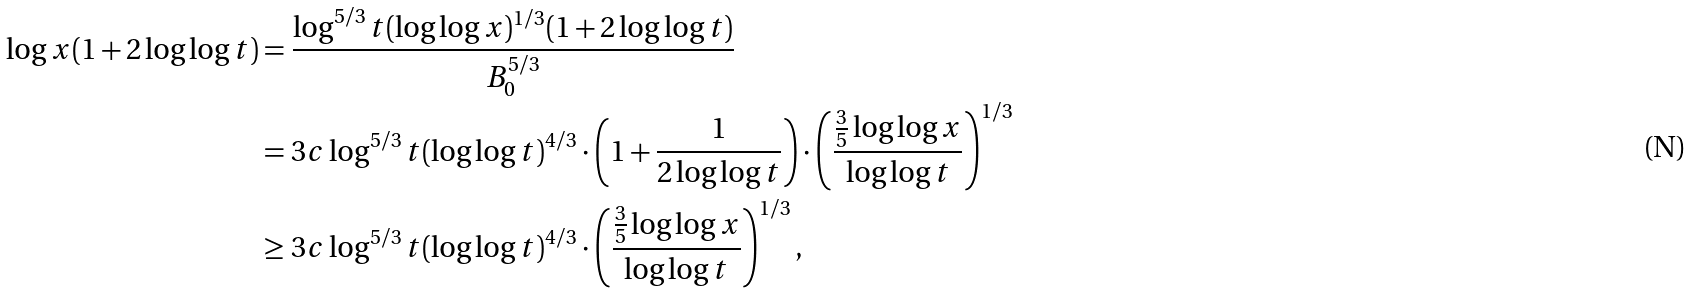Convert formula to latex. <formula><loc_0><loc_0><loc_500><loc_500>\log x ( 1 + 2 \log \log t ) & = \frac { \log ^ { 5 / 3 } t ( \log \log x ) ^ { 1 / 3 } ( 1 + 2 \log \log t ) } { B _ { 0 } ^ { 5 / 3 } } \\ & = 3 c \log ^ { 5 / 3 } t ( \log \log t ) ^ { 4 / 3 } \cdot \left ( 1 + \frac { 1 } { 2 \log \log t } \right ) \cdot \left ( \frac { \frac { 3 } { 5 } \log \log x } { \log \log t } \right ) ^ { 1 / 3 } \\ & \geq 3 c \log ^ { 5 / 3 } t ( \log \log t ) ^ { 4 / 3 } \cdot \left ( \frac { \frac { 3 } { 5 } \log \log x } { \log \log t } \right ) ^ { 1 / 3 } ,</formula> 